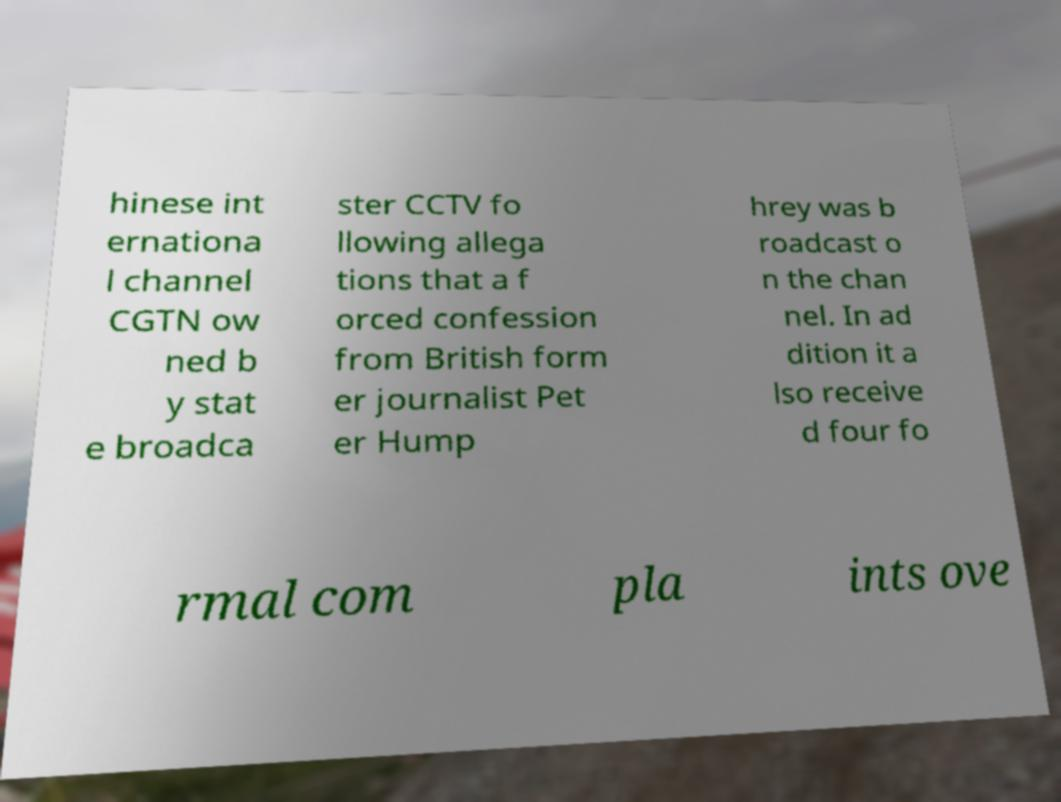Could you assist in decoding the text presented in this image and type it out clearly? hinese int ernationa l channel CGTN ow ned b y stat e broadca ster CCTV fo llowing allega tions that a f orced confession from British form er journalist Pet er Hump hrey was b roadcast o n the chan nel. In ad dition it a lso receive d four fo rmal com pla ints ove 